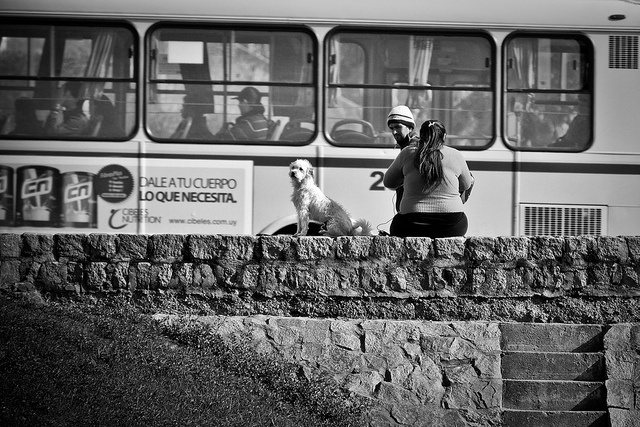Describe the objects in this image and their specific colors. I can see bus in gray, darkgray, black, and lightgray tones, people in gray, black, lightgray, and darkgray tones, dog in gray, lightgray, darkgray, and black tones, people in black and gray tones, and people in gray, darkgray, and lightgray tones in this image. 